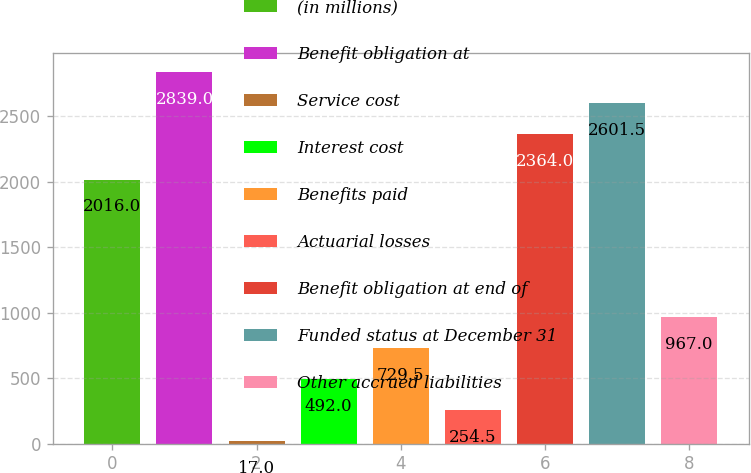<chart> <loc_0><loc_0><loc_500><loc_500><bar_chart><fcel>(in millions)<fcel>Benefit obligation at<fcel>Service cost<fcel>Interest cost<fcel>Benefits paid<fcel>Actuarial losses<fcel>Benefit obligation at end of<fcel>Funded status at December 31<fcel>Other accrued liabilities<nl><fcel>2016<fcel>2839<fcel>17<fcel>492<fcel>729.5<fcel>254.5<fcel>2364<fcel>2601.5<fcel>967<nl></chart> 